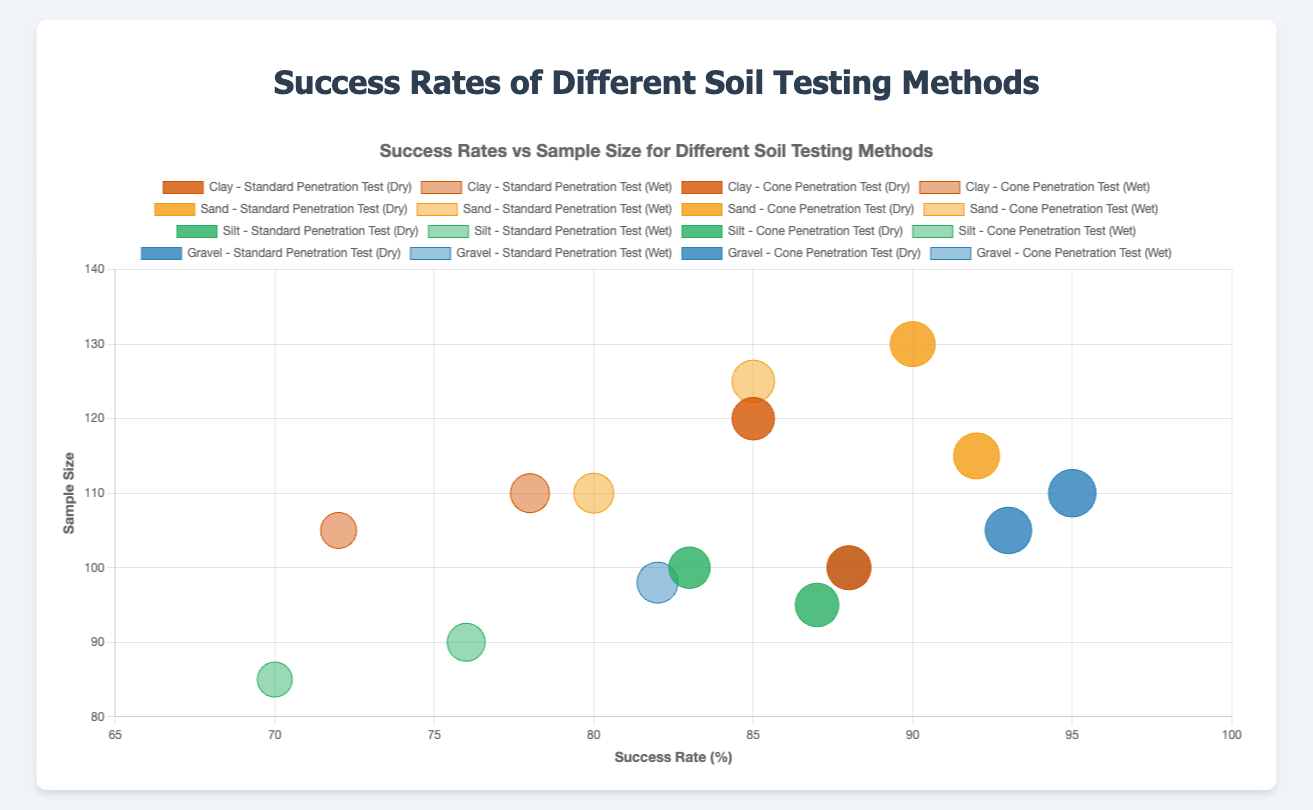What's the title of the chart? The title of the chart is displayed at the top and reads "Success Rates vs Sample Size for Different Soil Testing Methods."
Answer: Success Rates vs Sample Size for Different Soil Testing Methods What is shown on the x-axis of the chart? The x-axis of the chart is labeled 'Success Rate (%)', which indicates the success rate of different soil testing methods.
Answer: Success Rate (%) Which soil type and testing method had the highest success rate in dry weather conditions? By scanning the bubbles in the chart for dry weather conditions, the largest x-value (success rate) for dry conditions is observed for Gravel using Cone Penetration Test.
Answer: Gravel - Cone Penetration Test Which weather condition generally shows higher success rates for soil testing methods? By comparing the colors representing dry and wet conditions across different soil types and methods, dry conditions typically have higher success rates as their corresponding bubbles are plotted further along the x-axis.
Answer: Dry What's the average success rate for the Standard Penetration Test across all soil types in wet conditions? To find this, add the success rates of the Standard Penetration Test under wet conditions for all soil types and divide by the number of data points: (78 + 85 + 76 + 88) / 4 = 81.75%.
Answer: 81.75% How do the success rates for the Cone Penetration Test compare in dry vs. wet conditions for Clay soil type? For Clay soil type, the success rates for Cone Penetration Test are 88% (dry) and 72% (wet). By comparing these, 88% is greater than 72%.
Answer: Dry > Wet Which soil type has the smallest sample size for the testing methods in wet conditions? By inspecting the y-axis values for wet conditions, the smallest sample size is associated with Silt using Cone Penetration Test with a sample size of 85.
Answer: Silt - Cone Penetration Test If you sum up all the success rates for Gravel soil type across all testing methods and weather conditions, what would it be? Sum the success rates for Gravel from all test methods and weather conditions: 93 (Dry - SPT) + 88 (Wet - SPT) + 95 (Dry - CPT) + 82 (Wet - CPT) = 358.
Answer: 358 What's the difference in the sample size between the highest and lowest success rate conditions for Sand using Standard Penetration Test? The success rates for Sand using Standard Penetration Test are 90% (Dry, 130) and 85% (Wet, 125). Difference in sample size is 130 - 125 = 5.
Answer: 5 Which soil testing method appears to be most consistent regardless of weather conditions based on success rate? By examining the difference in success rates for each testing method across all soil types between dry and wet conditions, Standard Penetration Test shows smaller fluctuations compared to Cone Penetration Test, indicating higher consistency.
Answer: Standard Penetration Test 